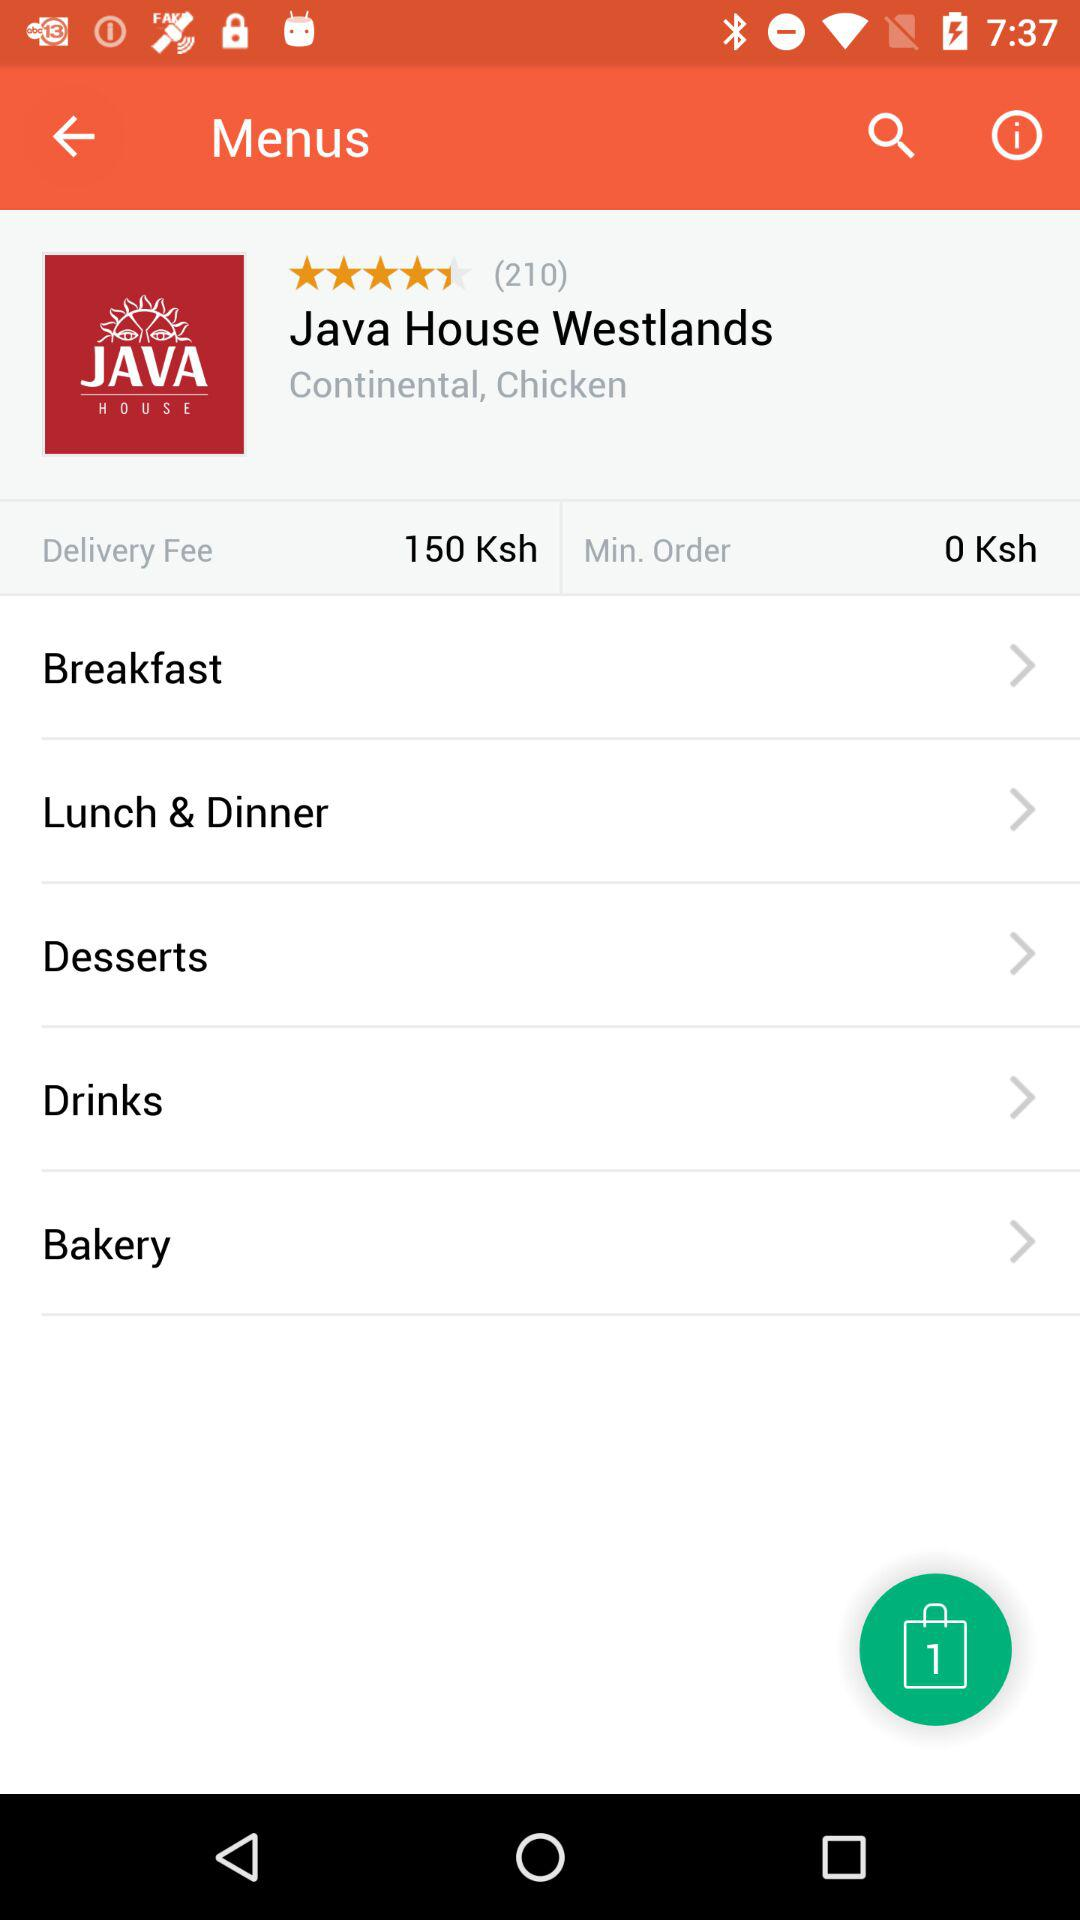How many user rated? There are 210 users. 